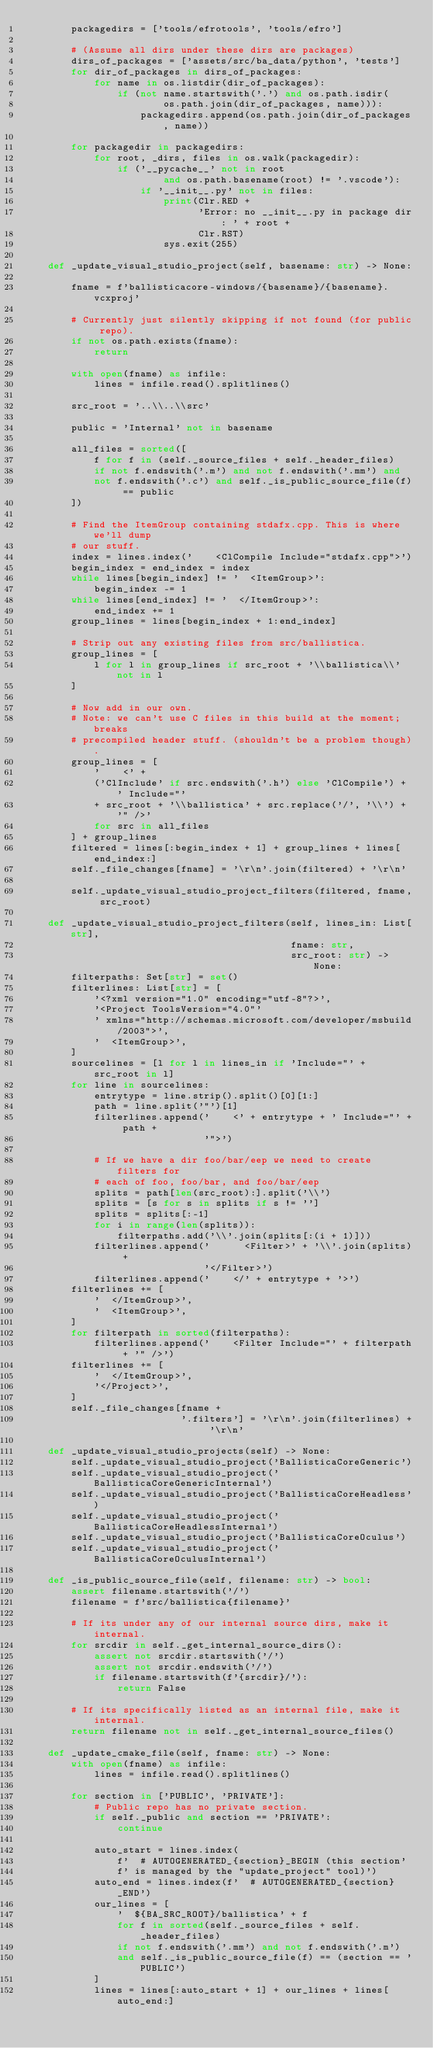<code> <loc_0><loc_0><loc_500><loc_500><_Python_>        packagedirs = ['tools/efrotools', 'tools/efro']

        # (Assume all dirs under these dirs are packages)
        dirs_of_packages = ['assets/src/ba_data/python', 'tests']
        for dir_of_packages in dirs_of_packages:
            for name in os.listdir(dir_of_packages):
                if (not name.startswith('.') and os.path.isdir(
                        os.path.join(dir_of_packages, name))):
                    packagedirs.append(os.path.join(dir_of_packages, name))

        for packagedir in packagedirs:
            for root, _dirs, files in os.walk(packagedir):
                if ('__pycache__' not in root
                        and os.path.basename(root) != '.vscode'):
                    if '__init__.py' not in files:
                        print(Clr.RED +
                              'Error: no __init__.py in package dir: ' + root +
                              Clr.RST)
                        sys.exit(255)

    def _update_visual_studio_project(self, basename: str) -> None:

        fname = f'ballisticacore-windows/{basename}/{basename}.vcxproj'

        # Currently just silently skipping if not found (for public repo).
        if not os.path.exists(fname):
            return

        with open(fname) as infile:
            lines = infile.read().splitlines()

        src_root = '..\\..\\src'

        public = 'Internal' not in basename

        all_files = sorted([
            f for f in (self._source_files + self._header_files)
            if not f.endswith('.m') and not f.endswith('.mm') and
            not f.endswith('.c') and self._is_public_source_file(f) == public
        ])

        # Find the ItemGroup containing stdafx.cpp. This is where we'll dump
        # our stuff.
        index = lines.index('    <ClCompile Include="stdafx.cpp">')
        begin_index = end_index = index
        while lines[begin_index] != '  <ItemGroup>':
            begin_index -= 1
        while lines[end_index] != '  </ItemGroup>':
            end_index += 1
        group_lines = lines[begin_index + 1:end_index]

        # Strip out any existing files from src/ballistica.
        group_lines = [
            l for l in group_lines if src_root + '\\ballistica\\' not in l
        ]

        # Now add in our own.
        # Note: we can't use C files in this build at the moment; breaks
        # precompiled header stuff. (shouldn't be a problem though).
        group_lines = [
            '    <' +
            ('ClInclude' if src.endswith('.h') else 'ClCompile') + ' Include="'
            + src_root + '\\ballistica' + src.replace('/', '\\') + '" />'
            for src in all_files
        ] + group_lines
        filtered = lines[:begin_index + 1] + group_lines + lines[end_index:]
        self._file_changes[fname] = '\r\n'.join(filtered) + '\r\n'

        self._update_visual_studio_project_filters(filtered, fname, src_root)

    def _update_visual_studio_project_filters(self, lines_in: List[str],
                                              fname: str,
                                              src_root: str) -> None:
        filterpaths: Set[str] = set()
        filterlines: List[str] = [
            '<?xml version="1.0" encoding="utf-8"?>',
            '<Project ToolsVersion="4.0"'
            ' xmlns="http://schemas.microsoft.com/developer/msbuild/2003">',
            '  <ItemGroup>',
        ]
        sourcelines = [l for l in lines_in if 'Include="' + src_root in l]
        for line in sourcelines:
            entrytype = line.strip().split()[0][1:]
            path = line.split('"')[1]
            filterlines.append('    <' + entrytype + ' Include="' + path +
                               '">')

            # If we have a dir foo/bar/eep we need to create filters for
            # each of foo, foo/bar, and foo/bar/eep
            splits = path[len(src_root):].split('\\')
            splits = [s for s in splits if s != '']
            splits = splits[:-1]
            for i in range(len(splits)):
                filterpaths.add('\\'.join(splits[:(i + 1)]))
            filterlines.append('      <Filter>' + '\\'.join(splits) +
                               '</Filter>')
            filterlines.append('    </' + entrytype + '>')
        filterlines += [
            '  </ItemGroup>',
            '  <ItemGroup>',
        ]
        for filterpath in sorted(filterpaths):
            filterlines.append('    <Filter Include="' + filterpath + '" />')
        filterlines += [
            '  </ItemGroup>',
            '</Project>',
        ]
        self._file_changes[fname +
                           '.filters'] = '\r\n'.join(filterlines) + '\r\n'

    def _update_visual_studio_projects(self) -> None:
        self._update_visual_studio_project('BallisticaCoreGeneric')
        self._update_visual_studio_project('BallisticaCoreGenericInternal')
        self._update_visual_studio_project('BallisticaCoreHeadless')
        self._update_visual_studio_project('BallisticaCoreHeadlessInternal')
        self._update_visual_studio_project('BallisticaCoreOculus')
        self._update_visual_studio_project('BallisticaCoreOculusInternal')

    def _is_public_source_file(self, filename: str) -> bool:
        assert filename.startswith('/')
        filename = f'src/ballistica{filename}'

        # If its under any of our internal source dirs, make it internal.
        for srcdir in self._get_internal_source_dirs():
            assert not srcdir.startswith('/')
            assert not srcdir.endswith('/')
            if filename.startswith(f'{srcdir}/'):
                return False

        # If its specifically listed as an internal file, make it internal.
        return filename not in self._get_internal_source_files()

    def _update_cmake_file(self, fname: str) -> None:
        with open(fname) as infile:
            lines = infile.read().splitlines()

        for section in ['PUBLIC', 'PRIVATE']:
            # Public repo has no private section.
            if self._public and section == 'PRIVATE':
                continue

            auto_start = lines.index(
                f'  # AUTOGENERATED_{section}_BEGIN (this section'
                f' is managed by the "update_project" tool)')
            auto_end = lines.index(f'  # AUTOGENERATED_{section}_END')
            our_lines = [
                '  ${BA_SRC_ROOT}/ballistica' + f
                for f in sorted(self._source_files + self._header_files)
                if not f.endswith('.mm') and not f.endswith('.m')
                and self._is_public_source_file(f) == (section == 'PUBLIC')
            ]
            lines = lines[:auto_start + 1] + our_lines + lines[auto_end:]
</code> 